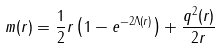Convert formula to latex. <formula><loc_0><loc_0><loc_500><loc_500>m ( r ) = \frac { 1 } { 2 } r \left ( 1 - e ^ { - 2 \Lambda ( r ) } \right ) + \frac { q ^ { 2 } ( r ) } { 2 r }</formula> 